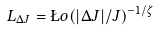<formula> <loc_0><loc_0><loc_500><loc_500>L _ { \Delta J } = \L o ( | \Delta J | / J ) ^ { - 1 / \zeta }</formula> 